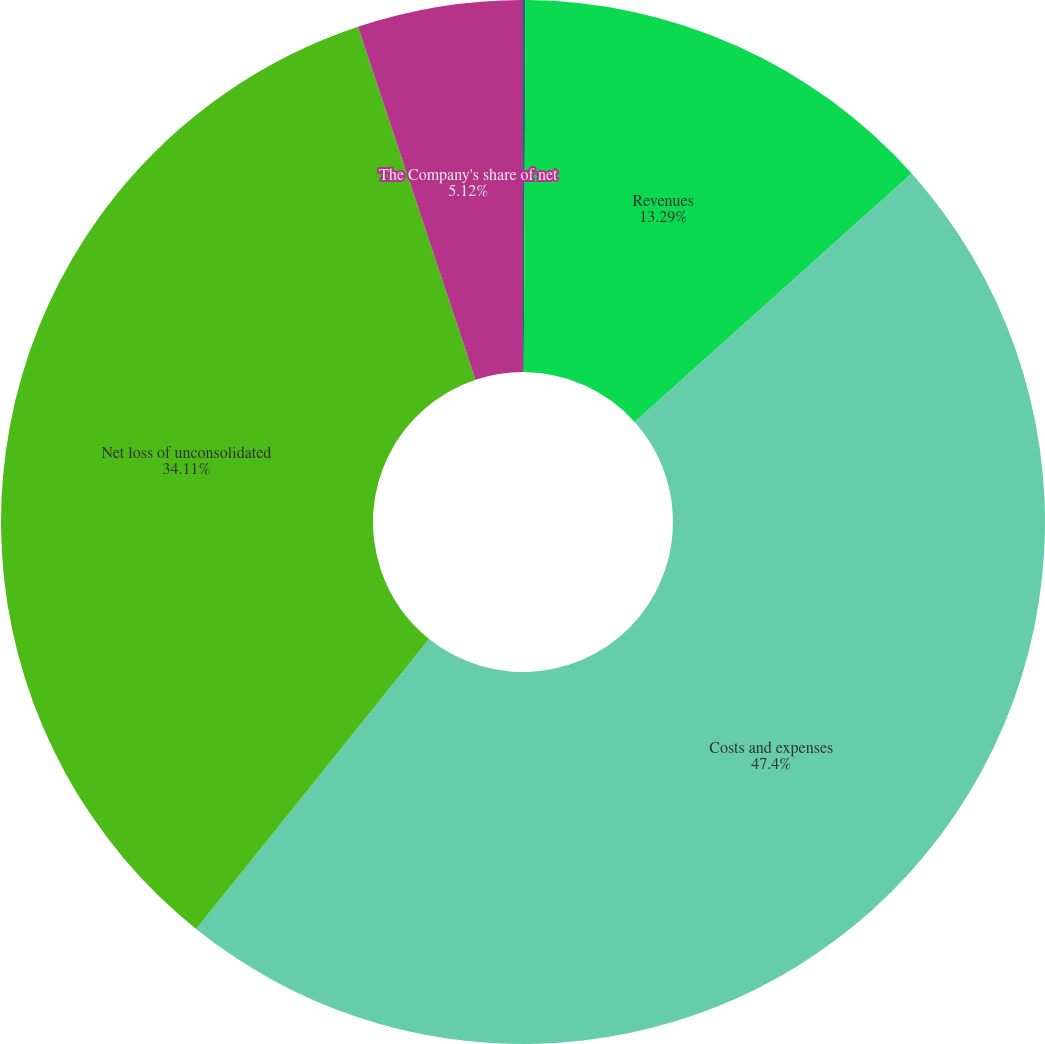Convert chart. <chart><loc_0><loc_0><loc_500><loc_500><pie_chart><fcel>Statements of Operations<fcel>Revenues<fcel>Costs and expenses<fcel>Net loss of unconsolidated<fcel>The Company's share of net<nl><fcel>0.08%<fcel>13.29%<fcel>47.4%<fcel>34.11%<fcel>5.12%<nl></chart> 